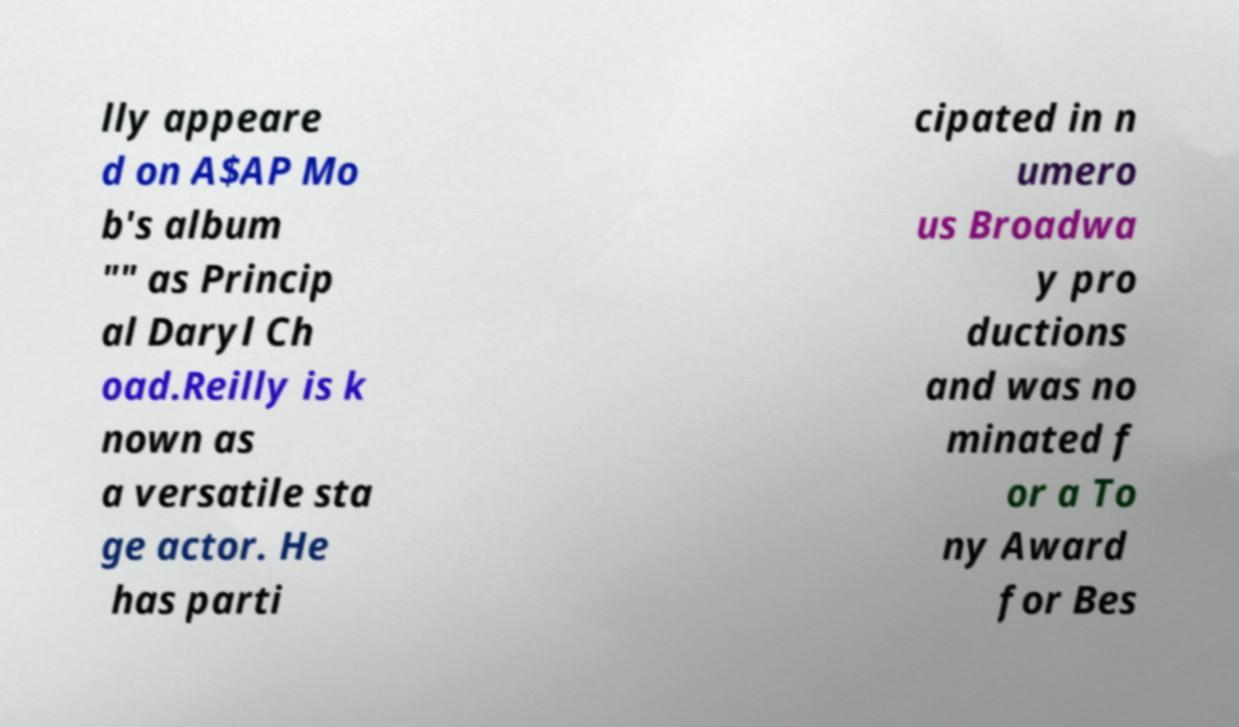For documentation purposes, I need the text within this image transcribed. Could you provide that? lly appeare d on A$AP Mo b's album "" as Princip al Daryl Ch oad.Reilly is k nown as a versatile sta ge actor. He has parti cipated in n umero us Broadwa y pro ductions and was no minated f or a To ny Award for Bes 